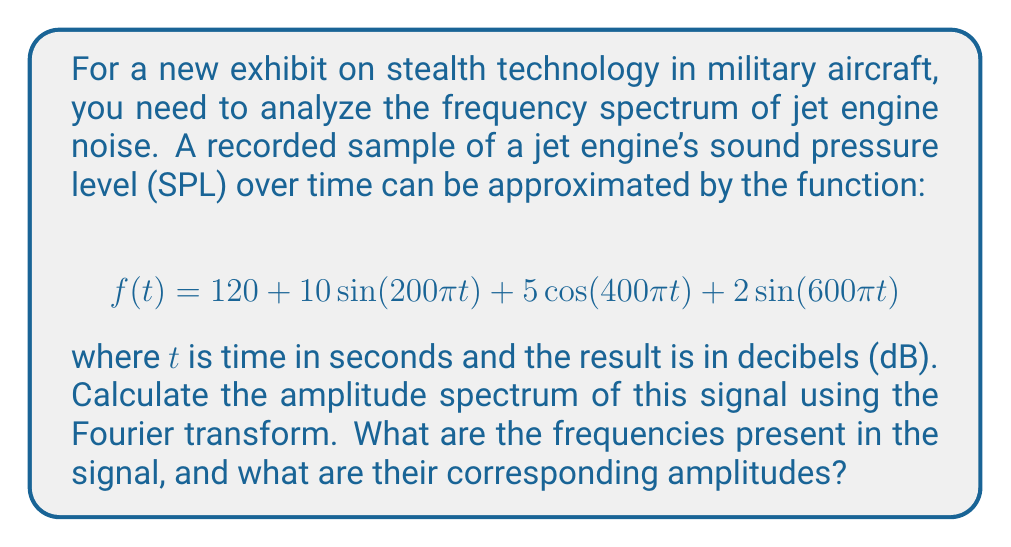Show me your answer to this math problem. To analyze the frequency spectrum of the given signal, we need to identify the sinusoidal components and their corresponding frequencies and amplitudes.

1. First, let's break down the function:
   $$f(t) = 120 + 10\sin(200\pi t) + 5\cos(400\pi t) + 2\sin(600\pi t)$$

2. The constant term 120 represents the DC component (0 Hz) in the frequency domain.

3. For each sinusoidal term, we can determine the frequency and amplitude:

   a) $10\sin(200\pi t)$:
      Frequency: $\frac{200\pi}{2\pi} = 100$ Hz
      Amplitude: 10 dB

   b) $5\cos(400\pi t)$:
      Frequency: $\frac{400\pi}{2\pi} = 200$ Hz
      Amplitude: 5 dB

   c) $2\sin(600\pi t)$:
      Frequency: $\frac{600\pi}{2\pi} = 300$ Hz
      Amplitude: 2 dB

4. The Fourier transform of a sinusoidal function results in impulses (delta functions) at the positive and negative frequencies. However, since we're dealing with real-world sound pressure levels, we only consider the positive frequencies.

5. The amplitude spectrum will show impulses at each of these frequencies, with heights corresponding to their amplitudes.

Therefore, the frequency spectrum of the jet engine noise consists of four components:
- A DC component at 0 Hz with amplitude 120 dB
- A component at 100 Hz with amplitude 10 dB
- A component at 200 Hz with amplitude 5 dB
- A component at 300 Hz with amplitude 2 dB
Answer: The frequency spectrum of the jet engine noise contains the following components:
- 0 Hz: 120 dB
- 100 Hz: 10 dB
- 200 Hz: 5 dB
- 300 Hz: 2 dB 